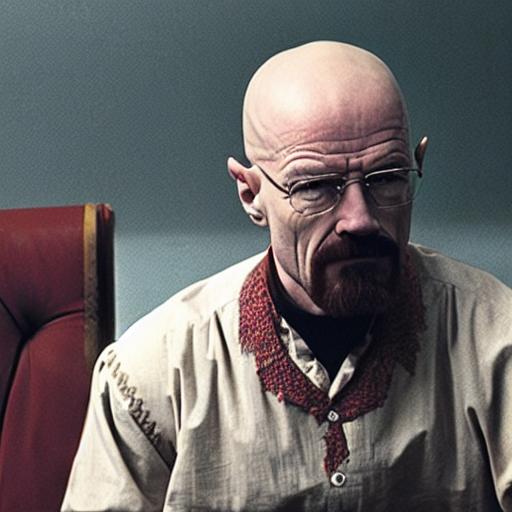Can you describe the person's expression and what it might convey? The person has a stern and intense expression, which suggests determination, grit, and potentially a readiness to confront challenges or complex situations. 